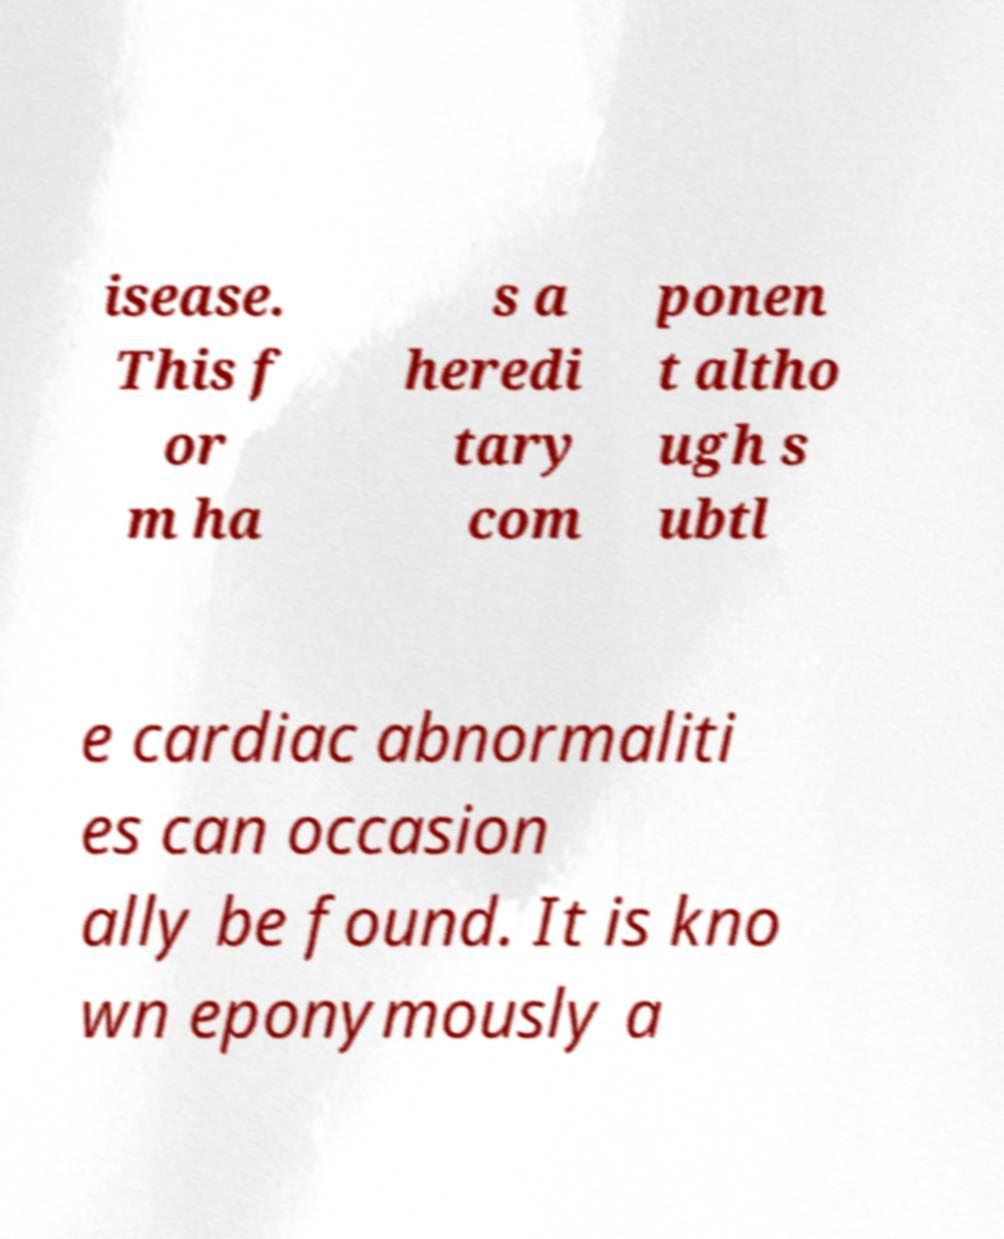Could you extract and type out the text from this image? isease. This f or m ha s a heredi tary com ponen t altho ugh s ubtl e cardiac abnormaliti es can occasion ally be found. It is kno wn eponymously a 